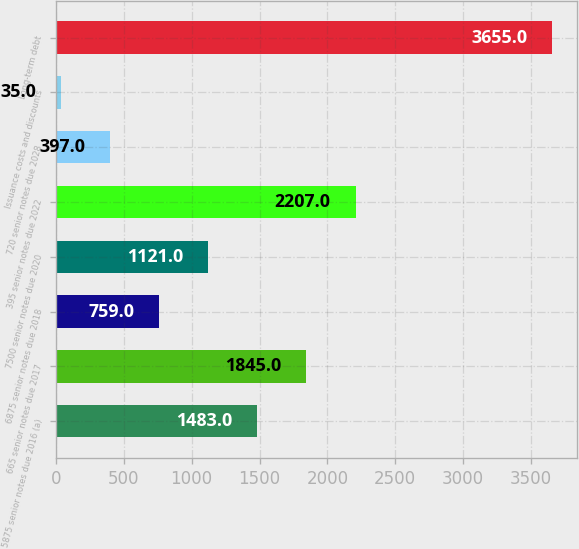<chart> <loc_0><loc_0><loc_500><loc_500><bar_chart><fcel>5875 senior notes due 2016 (a)<fcel>665 senior notes due 2017<fcel>6875 senior notes due 2018<fcel>7500 senior notes due 2020<fcel>395 senior notes due 2022<fcel>720 senior notes due 2028<fcel>Issuance costs and discounts<fcel>Long-term debt<nl><fcel>1483<fcel>1845<fcel>759<fcel>1121<fcel>2207<fcel>397<fcel>35<fcel>3655<nl></chart> 